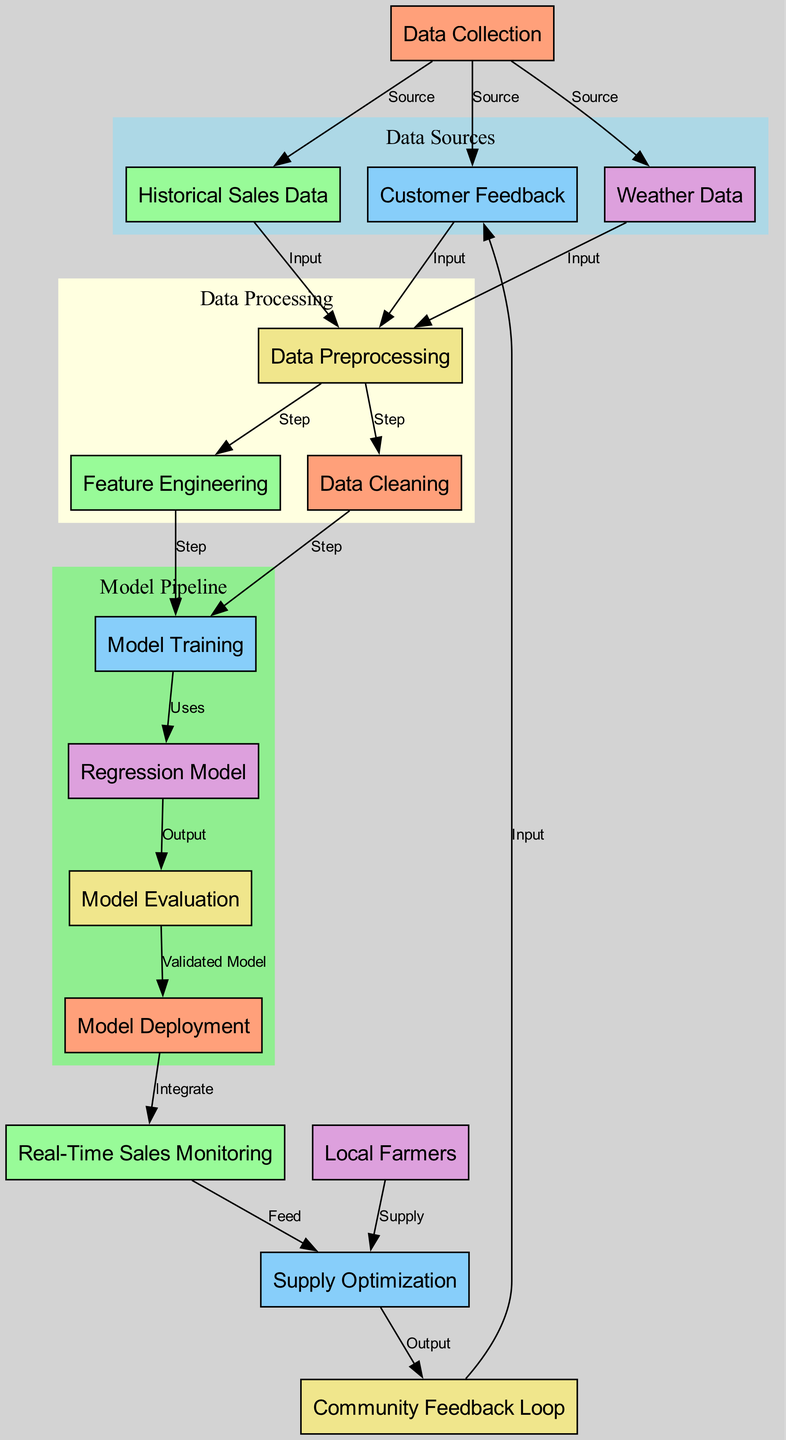What are the three data sources in the diagram? The three data sources mentioned in the diagram are "Historical Sales Data," "Customer Feedback," and "Weather Data." These nodes are grouped under the "Data Sources" section of the diagram.
Answer: Historical Sales Data, Customer Feedback, Weather Data How many nodes are present in the diagram? By counting all the listed nodes in the diagram, we find that there are a total of 14 nodes which are linked through various relationships.
Answer: 14 What is the output of the "Supply Optimization" node? The output of the "Supply Optimization" node is directed towards the "Community Feedback Loop" node, indicating that the optimized supply goes into this feedback system.
Answer: Community Feedback Loop What is the first step in the data preprocessing stage? The first step in the data preprocessing stage, as outlined in the diagram, is "Cleaning." This step comes before the feature engineering and model training phases.
Answer: Data Cleaning Which node feeds into "Supply Optimization"? Two nodes feed into "Supply Optimization": "Real-Time Sales Monitoring" and "Local Farmers." Both provide inputs needed for optimizing supply.
Answer: Real-Time Sales Monitoring, Local Farmers How is the "Regression Model" used in the diagram? The "Regression Model" is used after the "Model Training" process, which generates it. The model’s output then flows into "Model Evaluation" for the validation of its performance.
Answer: Model Training What links the "Customer Feedback" node to the "Data Collection" node? The relationship is labeled "Source," indicating that "Customer Feedback" is one of the sources feeding into the "Data Collection" stage of the diagram.
Answer: Source Which node is most closely related to "Model Evaluation"? "Regression Model" is the node most closely related to "Model Evaluation," as the evaluation is based on the output generated by the regression model.
Answer: Regression Model How does "Community Feedback Loop" relate back to the "Data Collection"? The "Community Feedback Loop" feeds its input back into "Customer Feedback," which is then part of the "Data Collection," creating a continuous cycle of improvement.
Answer: Customer Feedback 